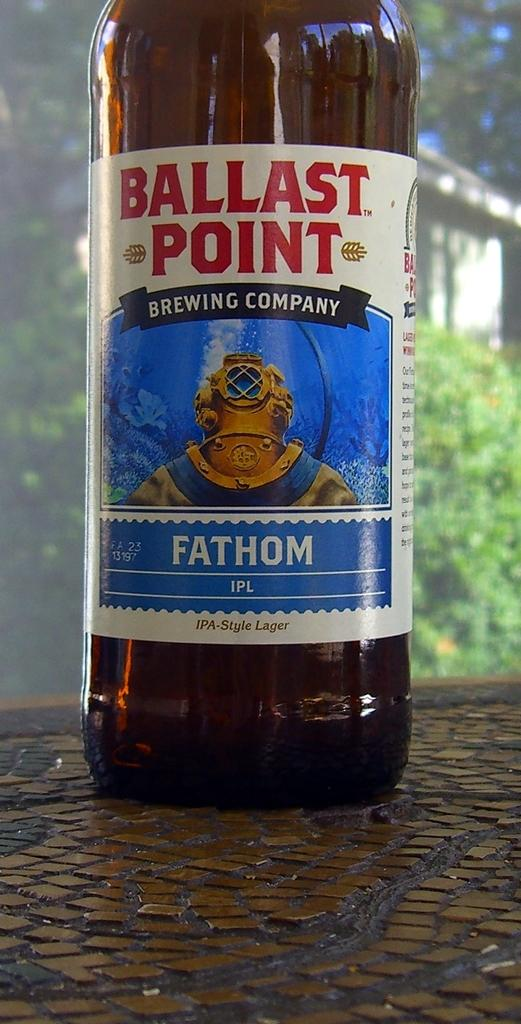<image>
Render a clear and concise summary of the photo. A beer that is called "Ballast Point" in on a table 